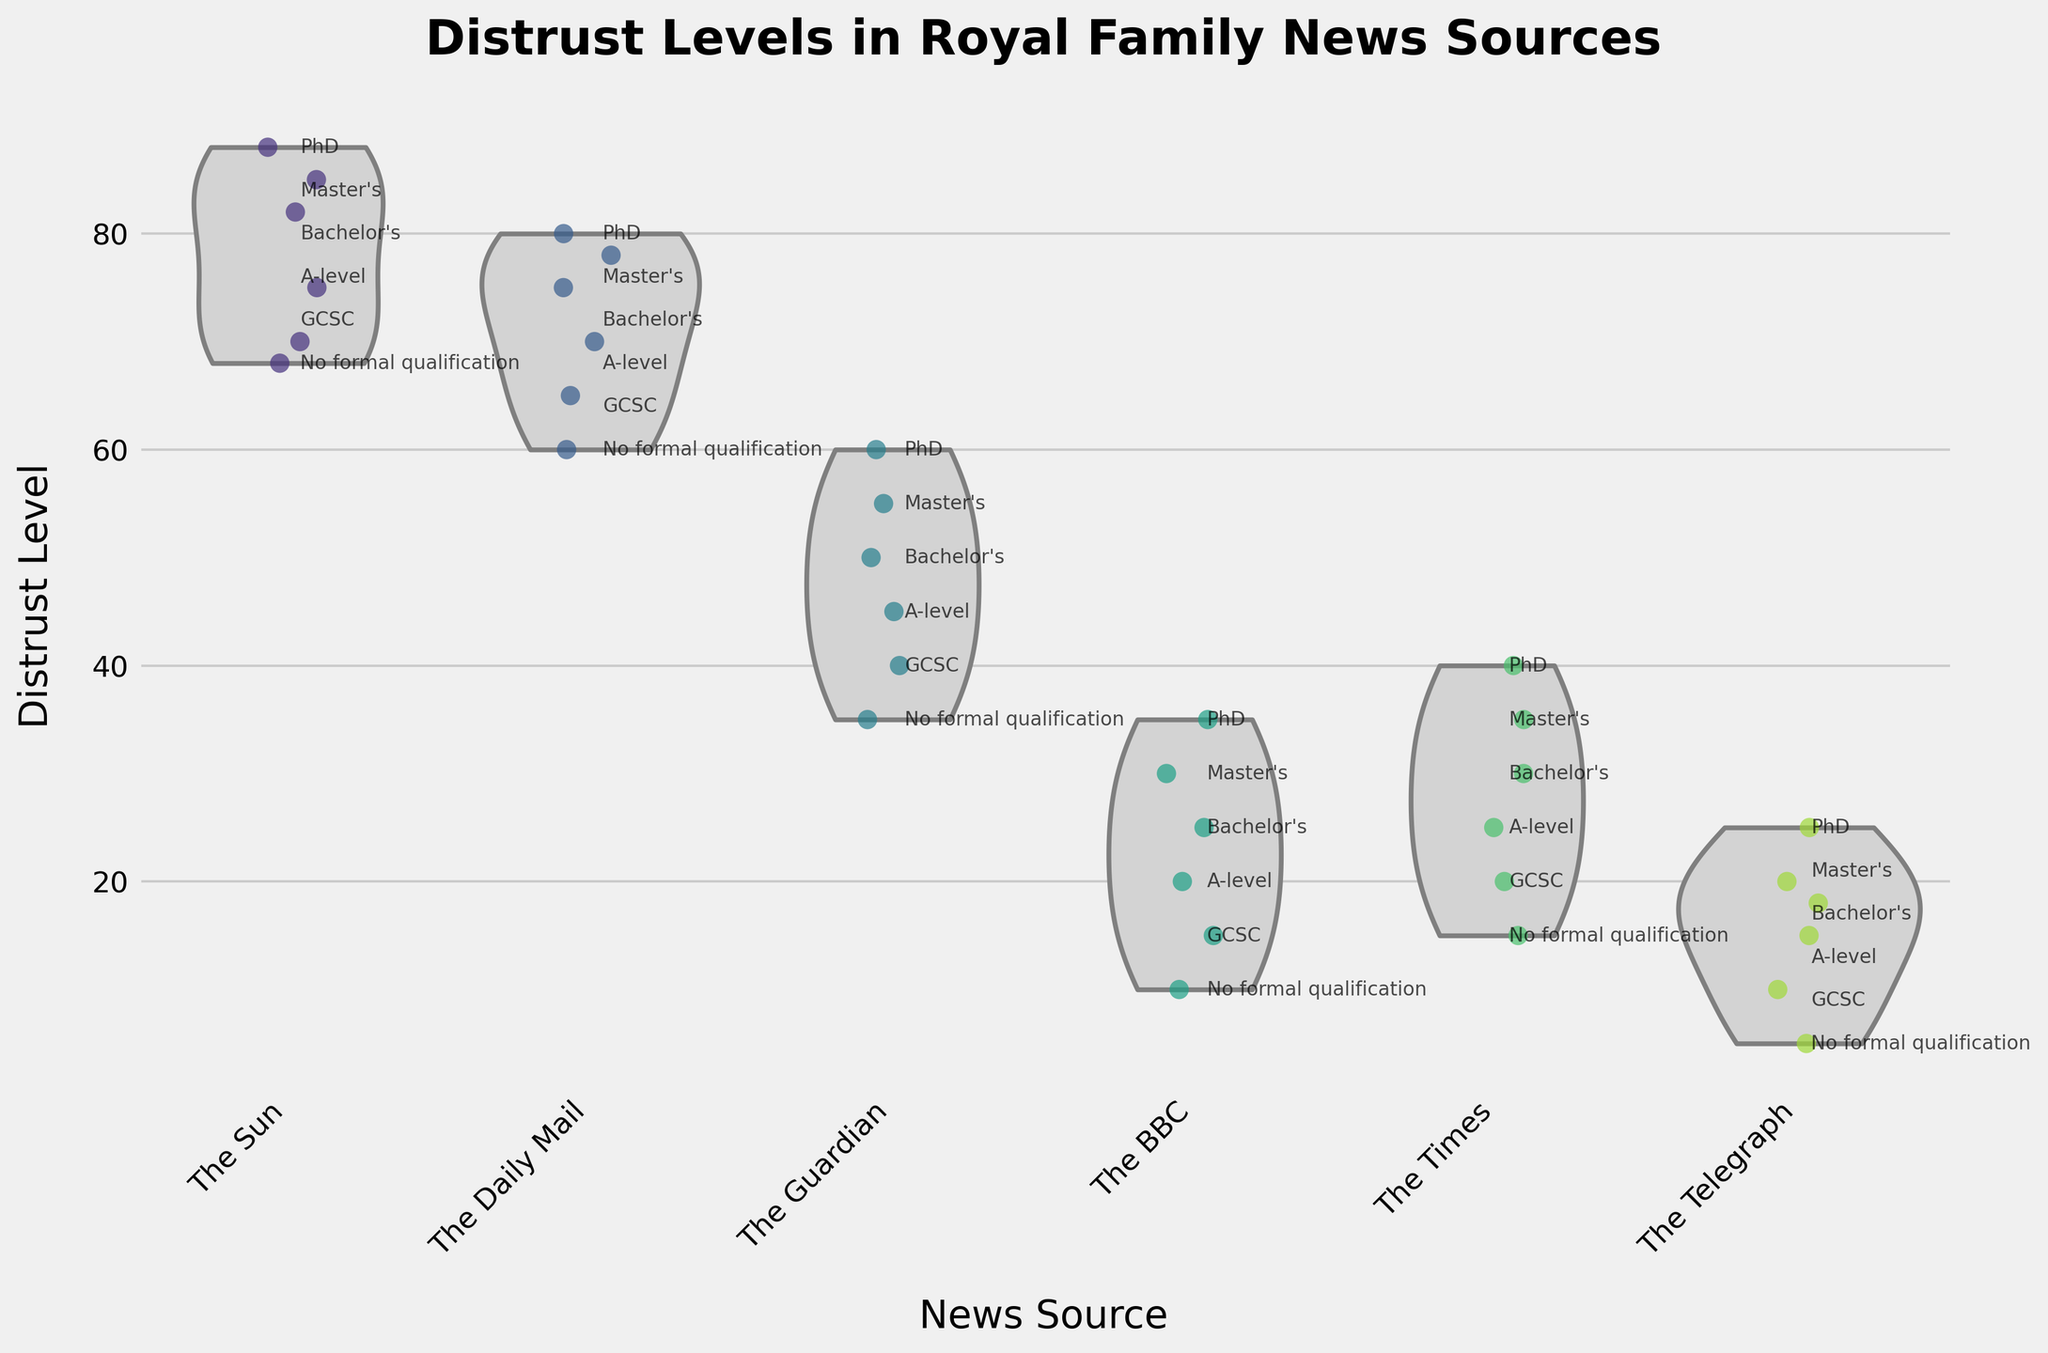What is the title of the plot? The title of the plot is displayed at the top in bold, larger font size.
Answer: Distrust Levels in Royal Family News Sources Which news source has the highest overall distrust levels? By observing the heights of the violin plots, we can see which violin extends the highest along the y-axis.
Answer: The Sun Which age group has the lowest distrust level for The Times? Look at the jittered points within the violin plot for The Times and find the corresponding label for the lowest point.
Answer: 55-64 How do distrust levels in The BBC vary with education among the 45-54 age group? For The BBC, observe the placement of the jittered points and the annotations within the violin plot to see the trend.
Answer: Distrust levels decrease with higher education What is the median distrust level for The Daily Mail? The median can be estimated by finding the middle value in the distribution of jittered points within The Daily Mail's violin plot.
Answer: Approximately 75 How does distrust level vary between PhD holders and No formal qualification holders for The Guardian? Compare the positions of jittered points for PhD and No formal qualification within The Guardian's violin plot.
Answer: PhD holders have significantly lower distrust levels Which education level has the highest distrust level in The Sun? Locate the highest jittered point in the violin plot for The Sun and find the corresponding educational annotation.
Answer: No formal qualification Which news source shows the most distinct trend of decreasing distrust levels with higher education? By observing the slopes and spread of the jittered points and annotations within each violin plot, find the one with the most consistent downward trend.
Answer: The Telegraph How do distrust levels compare between The Guardian and The Daily Mail across all education levels? Compare the spreads and positions of jittered points within the violin plots of The Guardian and The Daily Mail.
Answer: The Guardian generally has lower distrust levels than The Daily Mail Which news source has the most variation in distrust levels? Identify the widest violin plot along the y-axis, indicating the most spread and variation.
Answer: The Sun 